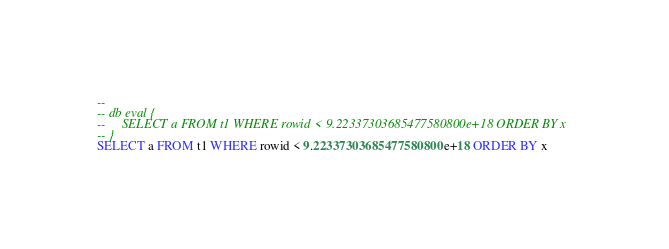Convert code to text. <code><loc_0><loc_0><loc_500><loc_500><_SQL_>-- 
-- db eval {
--     SELECT a FROM t1 WHERE rowid < 9.22337303685477580800e+18 ORDER BY x
-- }
SELECT a FROM t1 WHERE rowid < 9.22337303685477580800e+18 ORDER BY x</code> 